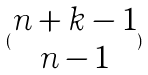Convert formula to latex. <formula><loc_0><loc_0><loc_500><loc_500>( \begin{matrix} n + k - 1 \\ n - 1 \end{matrix} )</formula> 